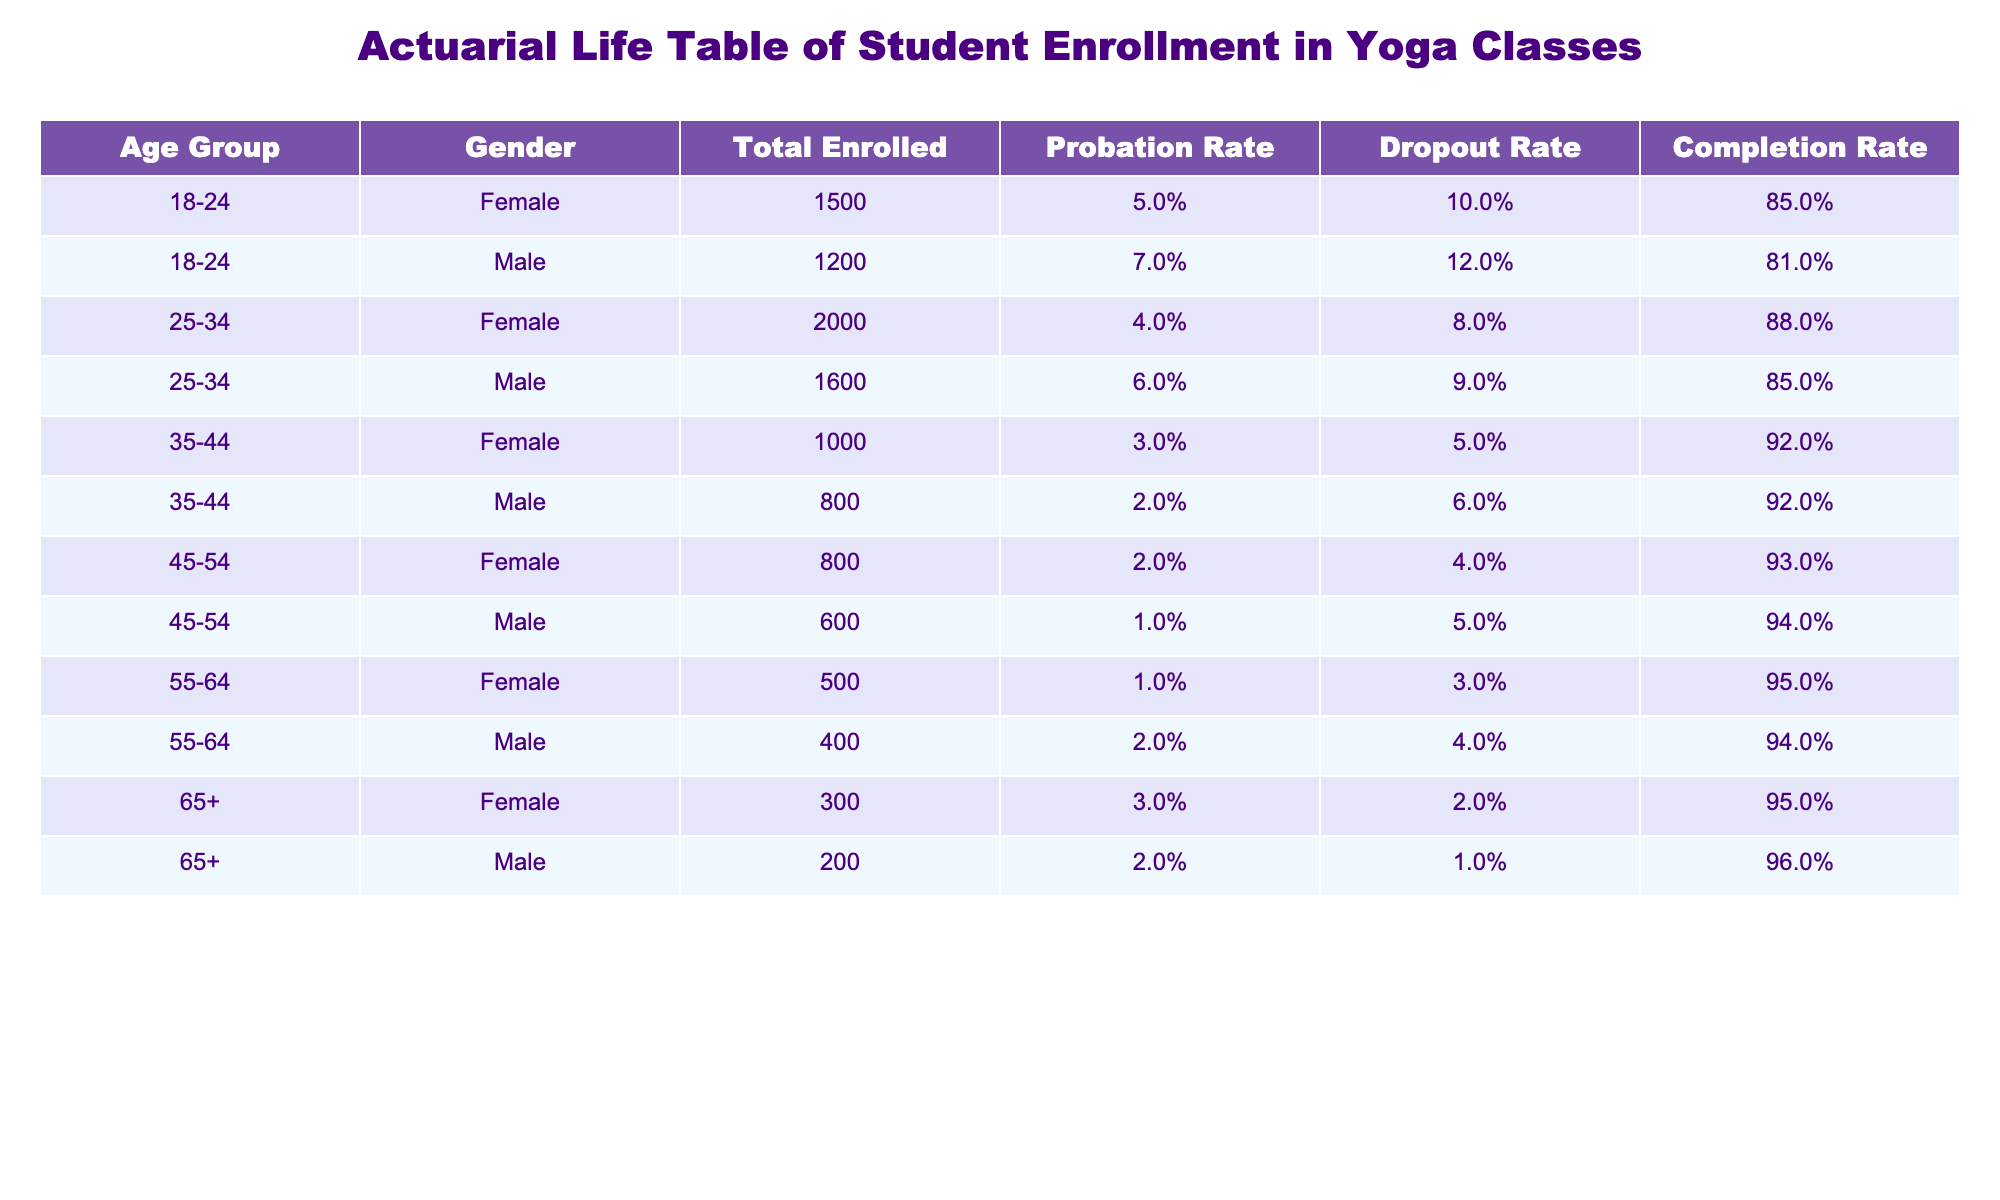What is the total number of females enrolled in the yoga classes? To find the total number of females enrolled, we sum the 'Total Enrolled' column for all the female rows: 1500 (18-24) + 2000 (25-34) + 1000 (35-44) + 800 (45-54) + 500 (55-64) + 300 (65+) = 5100.
Answer: 5100 What is the dropout rate for males aged 45-54? The dropout rate for males aged 45-54 can be directly found from the table: it shows a dropout rate of 5%.
Answer: 5% Which gender has a higher completion rate in the age group 25-34? By checking the completion rates in the table for 25-34, females have an 88% completion rate while males have an 85% completion rate. Therefore, females have a higher completion rate.
Answer: Females What is the average probation rate for students aged 35-44? The probation rates for 35-44 by gender are 3% for females and 2% for males. The average is (3 + 2) / 2 = 2.5%.
Answer: 2.5% Is the probation rate for males higher than for females in all age groups? We will examine each age group: for 18-24, males (7%) > females (5%). For 25-34, males (6%) < females (4%). For 35-44, males (2%) < females (3%). For 45-54, males (1%) < females (2%). For 55-64, males (2%) > females (1%). For 65+, males (2%) < females (3%). Since there are age groups where males have lower probation rates, the answer is no.
Answer: No What is the total enrolled for all students aged 65 and above? The total enrolled for students aged 65 and above is the sum of the enrolled numbers for both genders in that age group, which is 300 (females) + 200 (males) = 500.
Answer: 500 